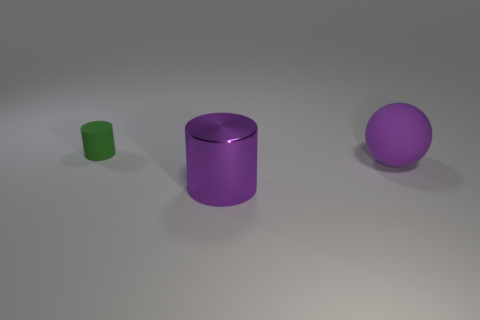Add 1 green objects. How many objects exist? 4 Subtract all balls. How many objects are left? 2 Add 2 big rubber balls. How many big rubber balls are left? 3 Add 2 small cyan matte balls. How many small cyan matte balls exist? 2 Subtract 0 gray cylinders. How many objects are left? 3 Subtract all large cylinders. Subtract all shiny cylinders. How many objects are left? 1 